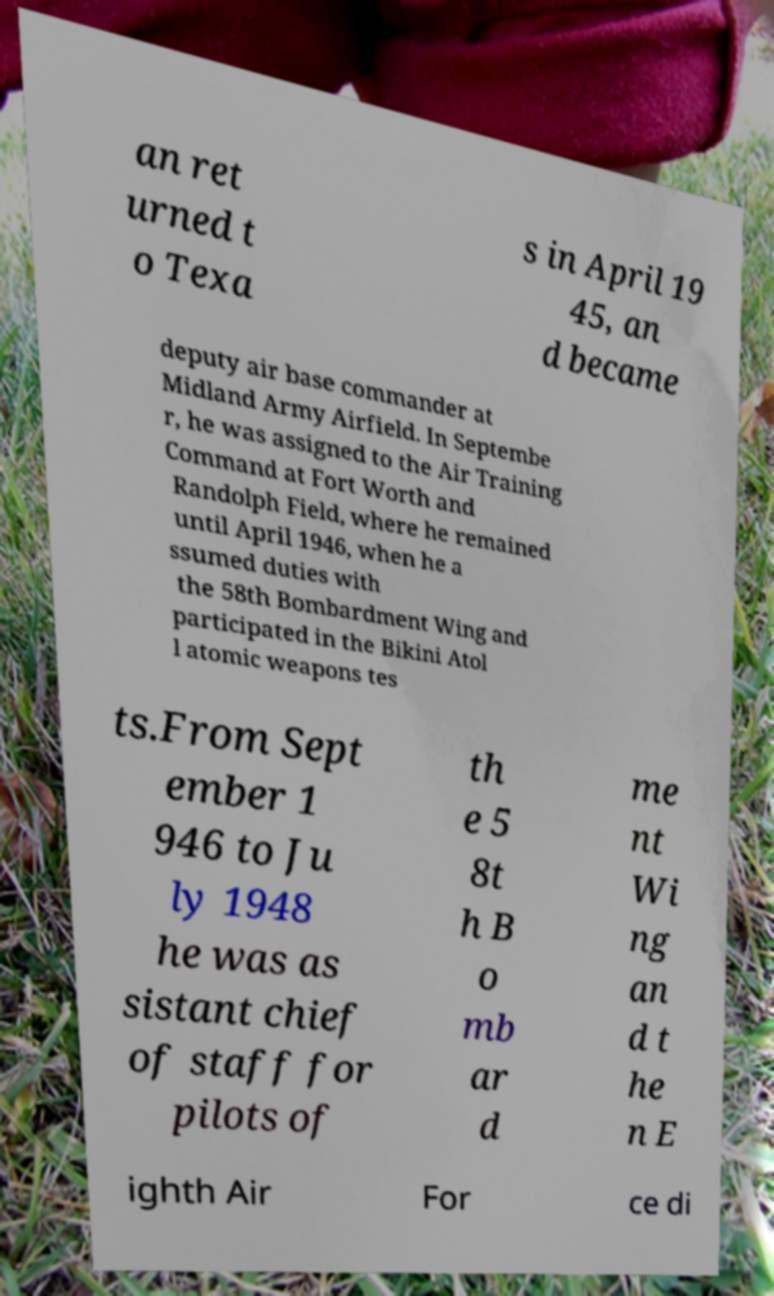Could you extract and type out the text from this image? an ret urned t o Texa s in April 19 45, an d became deputy air base commander at Midland Army Airfield. In Septembe r, he was assigned to the Air Training Command at Fort Worth and Randolph Field, where he remained until April 1946, when he a ssumed duties with the 58th Bombardment Wing and participated in the Bikini Atol l atomic weapons tes ts.From Sept ember 1 946 to Ju ly 1948 he was as sistant chief of staff for pilots of th e 5 8t h B o mb ar d me nt Wi ng an d t he n E ighth Air For ce di 